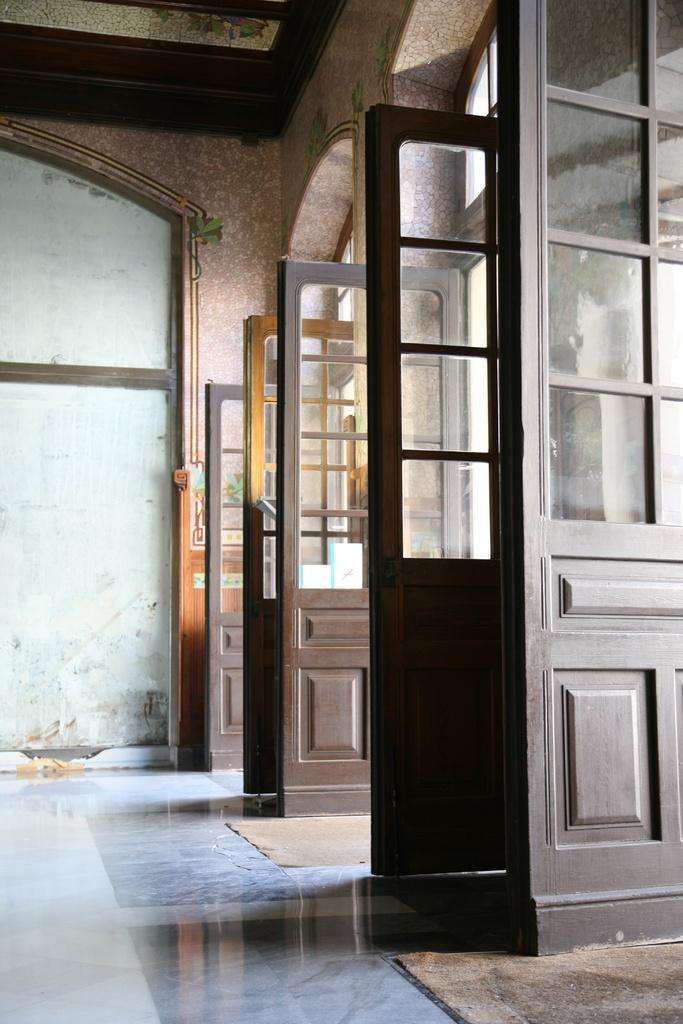What can be found in the image that allows access to different areas? There are doors in the image that allow access to different areas. What structure is located on the left side of the image? There is a wall on the left side of the image. Can you see a rabbit hopping around on the wall in the image? There is no rabbit present in the image; it only features doors and a wall. How many worms can be observed crawling on the doors in the image? There are no worms present in the image; it only features doors and a wall. 